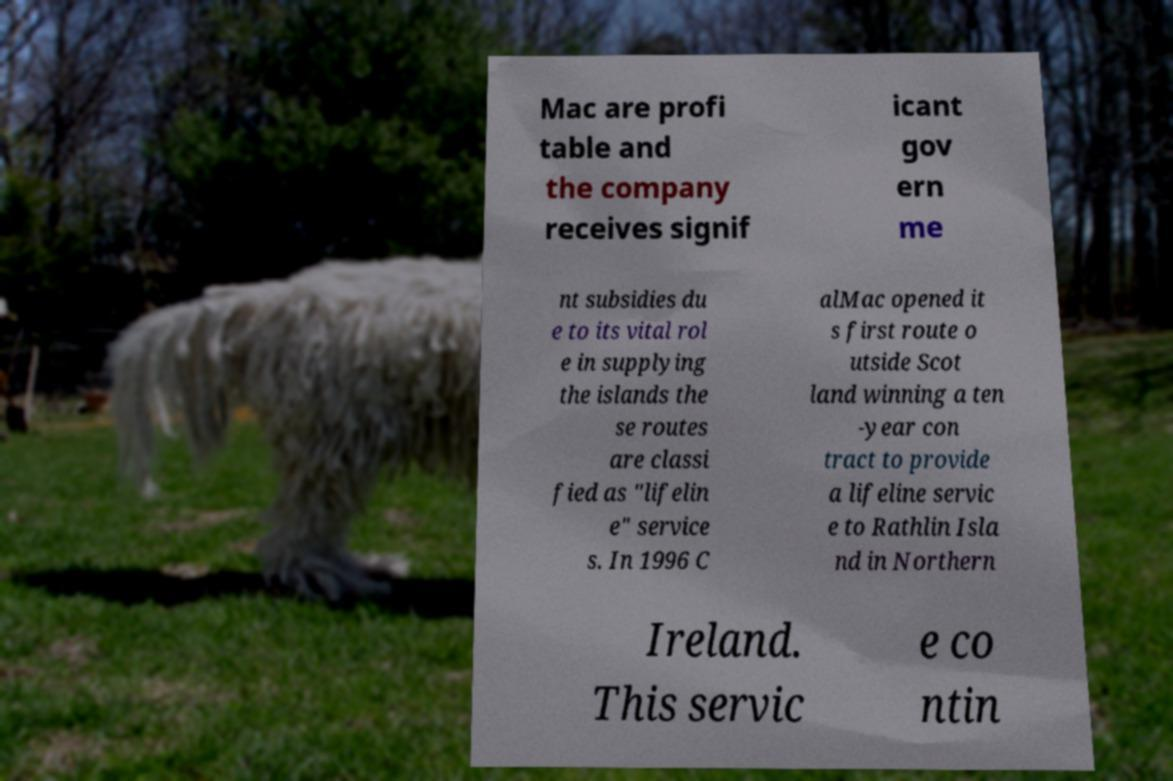For documentation purposes, I need the text within this image transcribed. Could you provide that? Mac are profi table and the company receives signif icant gov ern me nt subsidies du e to its vital rol e in supplying the islands the se routes are classi fied as "lifelin e" service s. In 1996 C alMac opened it s first route o utside Scot land winning a ten -year con tract to provide a lifeline servic e to Rathlin Isla nd in Northern Ireland. This servic e co ntin 